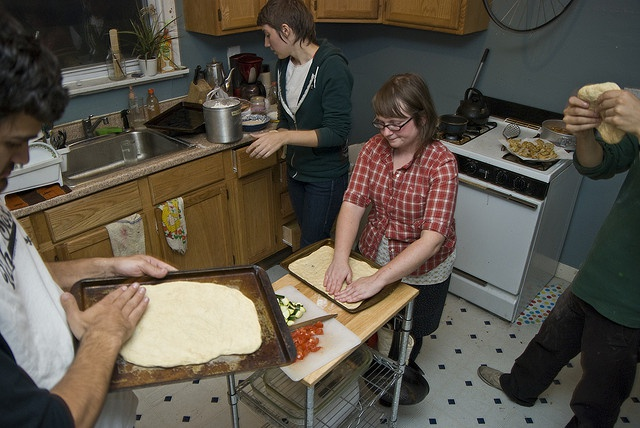Describe the objects in this image and their specific colors. I can see people in black, gray, and tan tones, people in black, maroon, brown, and gray tones, oven in black and gray tones, people in black, gray, and tan tones, and people in black, darkgray, tan, and gray tones in this image. 